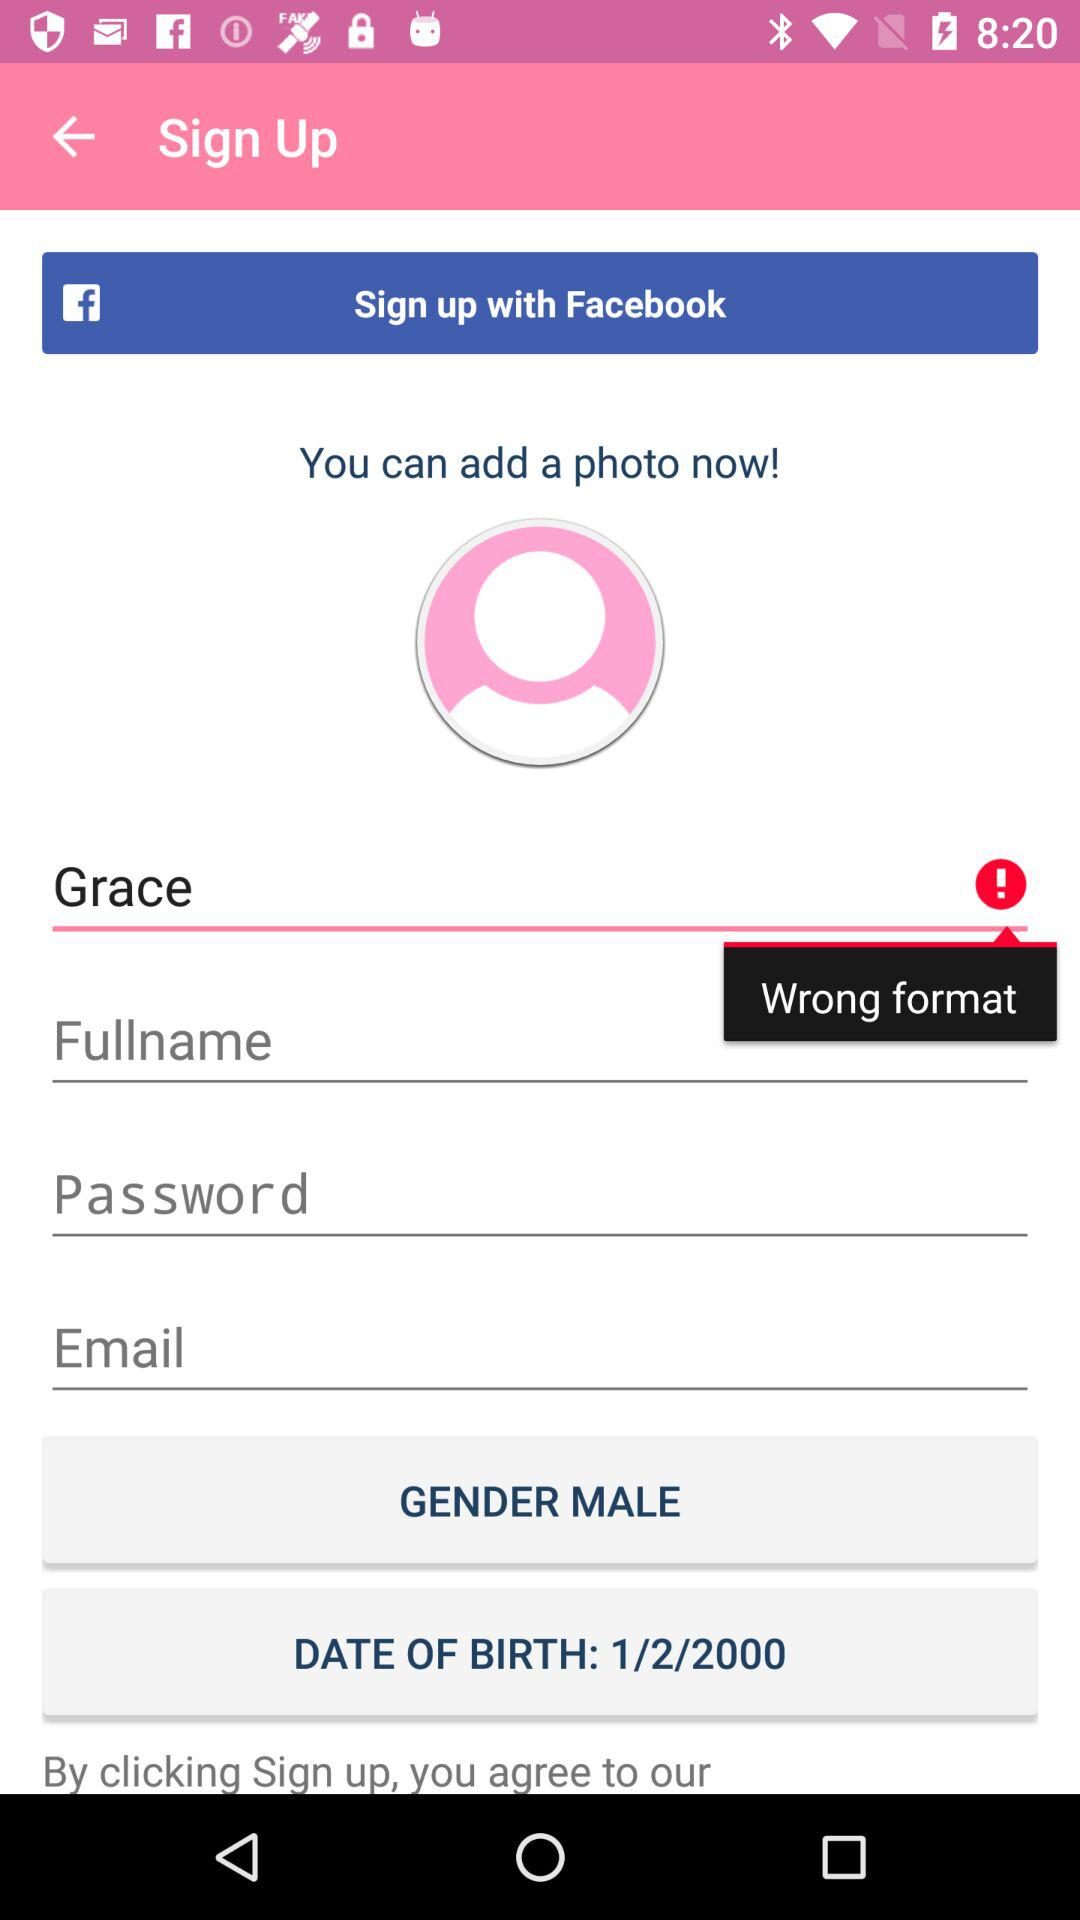What is the name? The name is Grace. 